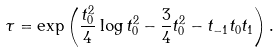<formula> <loc_0><loc_0><loc_500><loc_500>\tau = \exp \left ( \frac { t _ { 0 } ^ { 2 } } { 4 } \log t _ { 0 } ^ { 2 } - \frac { 3 } { 4 } t _ { 0 } ^ { 2 } - t _ { - 1 } t _ { 0 } t _ { 1 } \right ) .</formula> 